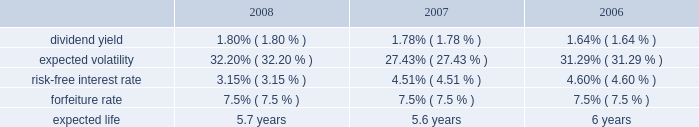N o t e s t o c o n s o l i d a t e d f i n a n c i a l s t a t e m e n t s ( continued ) ace limited and subsidiaries share-based compensation expense for stock options and shares issued under the employee stock purchase plan ( espp ) amounted to $ 24 million ( $ 22 million after tax or $ 0.07 per basic and diluted share ) , $ 23 million ( $ 21 million after tax or $ 0.06 per basic and diluted share ) , and $ 20 million ( $ 18 million after tax or $ 0.05 per basic and diluted share ) for the years ended december 31 , 2008 , 2007 , and 2006 , respectively .
For the years ended december 31 , 2008 , 2007 and 2006 , the expense for the restricted stock was $ 101 million ( $ 71 million after tax ) , $ 77 million ( $ 57 million after tax ) , and $ 65 million ( $ 49 million after tax ) , respectively .
During 2004 , the company established the ace limited 2004 long-term incentive plan ( the 2004 ltip ) .
Once the 2004 ltip was approved by shareholders , it became effective february 25 , 2004 .
It will continue in effect until terminated by the board .
This plan replaced the ace limited 1995 long-term incentive plan , the ace limited 1995 outside directors plan , the ace limited 1998 long-term incentive plan , and the ace limited 1999 replacement long-term incentive plan ( the prior plans ) except as to outstanding awards .
During the company 2019s 2008 annual general meeting , shareholders voted to increase the number of common shares authorized to be issued under the 2004 ltip from 15000000 common shares to 19000000 common shares .
Accordingly , under the 2004 ltip , a total of 19000000 common shares of the company are authorized to be issued pursuant to awards made as stock options , stock appreciation rights , performance shares , performance units , restricted stock , and restricted stock units .
The maximum number of shares that may be delivered to participants and their beneficiaries under the 2004 ltip shall be equal to the sum of : ( i ) 19000000 shares ; and ( ii ) any shares that are represented by awards granted under the prior plans that are forfeited , expired , or are canceled after the effective date of the 2004 ltip , without delivery of shares or which result in the forfeiture of the shares back to the company to the extent that such shares would have been added back to the reserve under the terms of the applicable prior plan .
As of december 31 , 2008 , a total of 10591090 shares remain available for future issuance under this plan .
Under the 2004 ltip , 3000000 common shares are authorized to be issued under the espp .
As of december 31 , 2008 , a total of 989812 common shares remain available for issuance under the espp .
Stock options the company 2019s 2004 ltip provides for grants of both incentive and non-qualified stock options principally at an option price per share of 100 percent of the fair value of the company 2019s common shares on the date of grant .
Stock options are generally granted with a 3-year vesting period and a 10-year term .
The stock options vest in equal annual installments over the respective vesting period , which is also the requisite service period .
Included in the company 2019s share-based compensation expense in the year ended december 31 , 2008 , is the cost related to the unvested portion of the 2005-2008 stock option grants .
The fair value of the stock options was estimated on the date of grant using the black-scholes option-pricing model that uses the assumptions noted in the table .
The risk-free inter- est rate is based on the u.s .
Treasury yield curve in effect at the time of grant .
The expected life ( estimated period of time from grant to exercise date ) was estimated using the historical exercise behavior of employees .
Expected volatility was calculated as a blend of ( a ) historical volatility based on daily closing prices over a period equal to the expected life assumption , ( b ) long- term historical volatility based on daily closing prices over the period from ace 2019s initial public trading date through the most recent quarter , and ( c ) implied volatility derived from ace 2019s publicly traded options .
The fair value of the options issued is estimated on the date of grant using the black-scholes option-pricing model , with the following weighted-average assumptions used for grants for the years indicated: .

What was the percentage increase in the number of common shares authorized to be issued under the 2004 ltip? 
Computations: ((19000000 - 15000000) / 15000000)
Answer: 0.26667. 